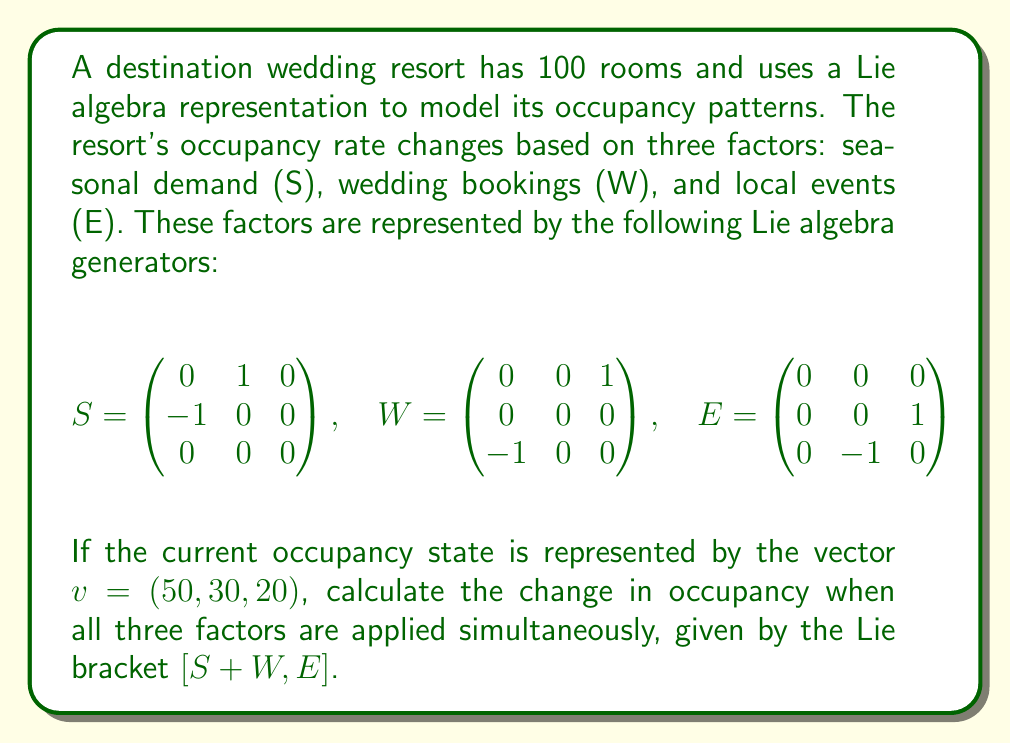Provide a solution to this math problem. To solve this problem, we'll follow these steps:

1) First, we need to calculate $S + W$:

   $$S + W = \begin{pmatrix} 0 & 1 & 1 \\ -1 & 0 & 0 \\ -1 & 0 & 0 \end{pmatrix}$$

2) Next, we calculate the Lie bracket $[S + W, E]$. The Lie bracket is defined as $[A, B] = AB - BA$:

   $$(S + W)E = \begin{pmatrix} 0 & 1 & 1 \\ -1 & 0 & 0 \\ -1 & 0 & 0 \end{pmatrix} \begin{pmatrix} 0 & 0 & 0 \\ 0 & 0 & 1 \\ 0 & -1 & 0 \end{pmatrix} = \begin{pmatrix} 0 & -1 & 1 \\ 0 & 0 & 0 \\ 0 & 0 & 0 \end{pmatrix}$$

   $$E(S + W) = \begin{pmatrix} 0 & 0 & 0 \\ 0 & 0 & 1 \\ 0 & -1 & 0 \end{pmatrix} \begin{pmatrix} 0 & 1 & 1 \\ -1 & 0 & 0 \\ -1 & 0 & 0 \end{pmatrix} = \begin{pmatrix} 0 & 0 & 0 \\ -1 & 0 & 0 \\ 1 & 0 & 0 \end{pmatrix}$$

   $$[S + W, E] = (S + W)E - E(S + W) = \begin{pmatrix} 0 & -1 & 1 \\ 1 & 0 & 0 \\ -1 & 0 & 0 \end{pmatrix}$$

3) To find the change in occupancy, we multiply this result by the current occupancy vector:

   $$\begin{pmatrix} 0 & -1 & 1 \\ 1 & 0 & 0 \\ -1 & 0 & 0 \end{pmatrix} \begin{pmatrix} 50 \\ 30 \\ 20 \end{pmatrix} = \begin{pmatrix} -10 \\ 50 \\ -50 \end{pmatrix}$$

4) This result represents the change in occupancy. The first component (-10) represents a decrease in seasonal demand, the second (50) an increase in wedding bookings, and the third (-50) a decrease in local event attendance.
Answer: $(-10, 50, -50)$ 